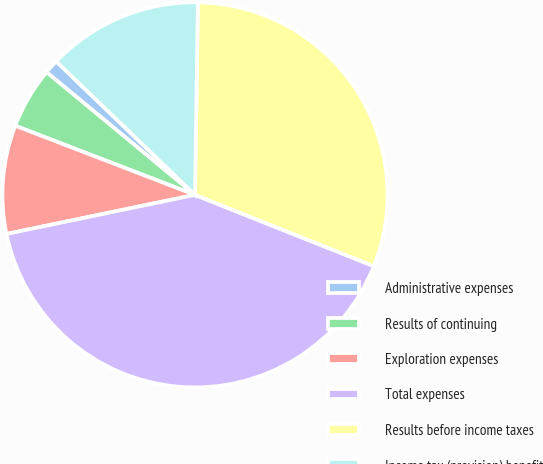<chart> <loc_0><loc_0><loc_500><loc_500><pie_chart><fcel>Administrative expenses<fcel>Results of continuing<fcel>Exploration expenses<fcel>Total expenses<fcel>Results before income taxes<fcel>Income tax (provision) benefit<nl><fcel>1.2%<fcel>5.15%<fcel>9.1%<fcel>40.71%<fcel>30.8%<fcel>13.05%<nl></chart> 